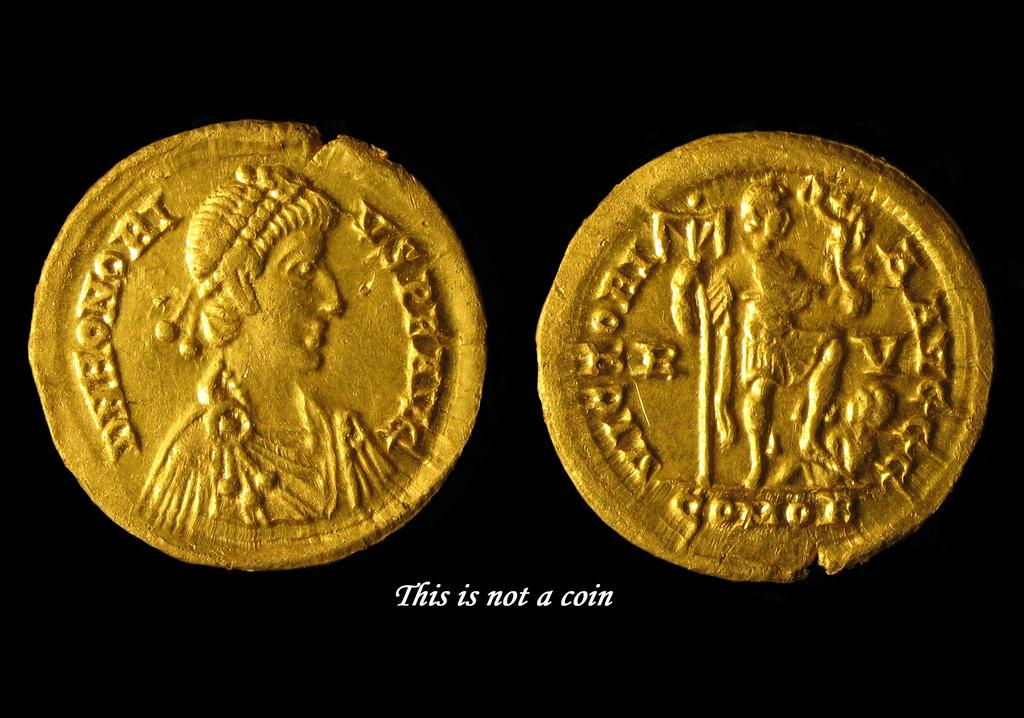Provide a one-sentence caption for the provided image. A photograph of two gold pieces has text which reads "this is not a coin". 